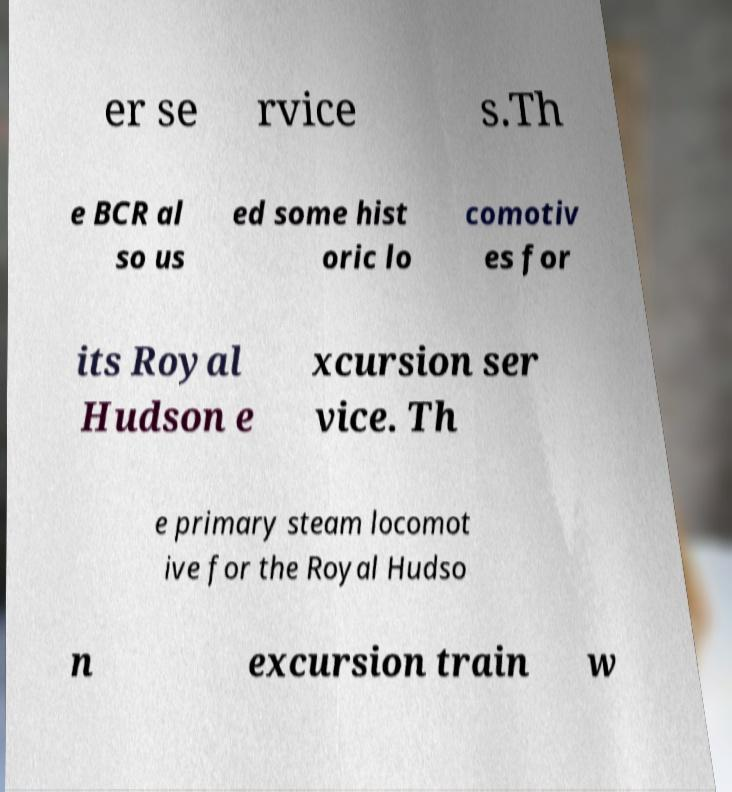What messages or text are displayed in this image? I need them in a readable, typed format. er se rvice s.Th e BCR al so us ed some hist oric lo comotiv es for its Royal Hudson e xcursion ser vice. Th e primary steam locomot ive for the Royal Hudso n excursion train w 